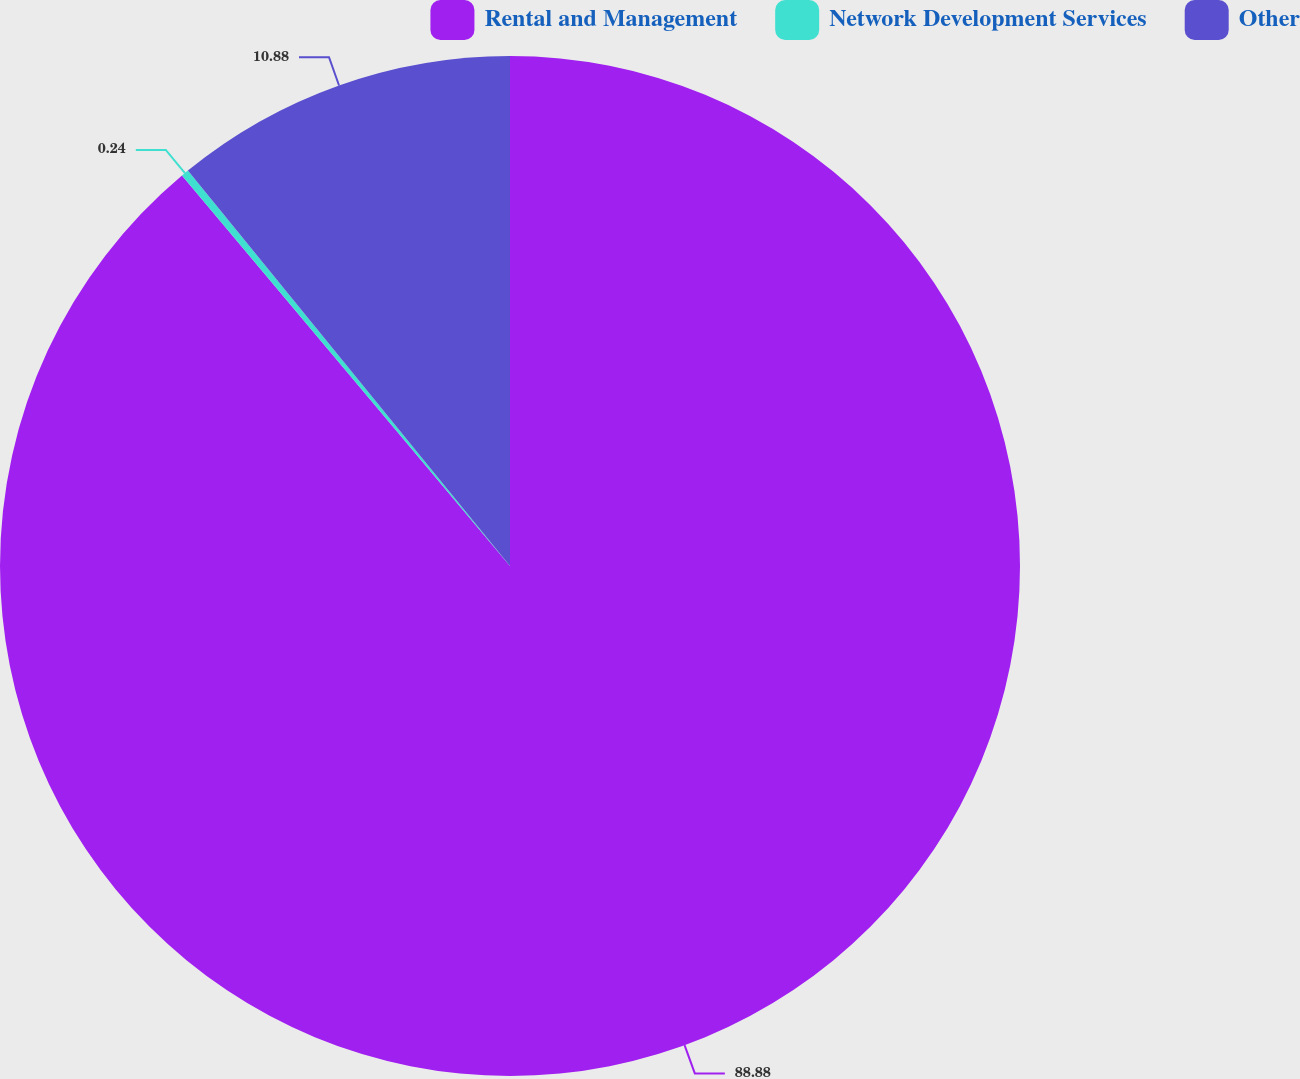Convert chart to OTSL. <chart><loc_0><loc_0><loc_500><loc_500><pie_chart><fcel>Rental and Management<fcel>Network Development Services<fcel>Other<nl><fcel>88.88%<fcel>0.24%<fcel>10.88%<nl></chart> 